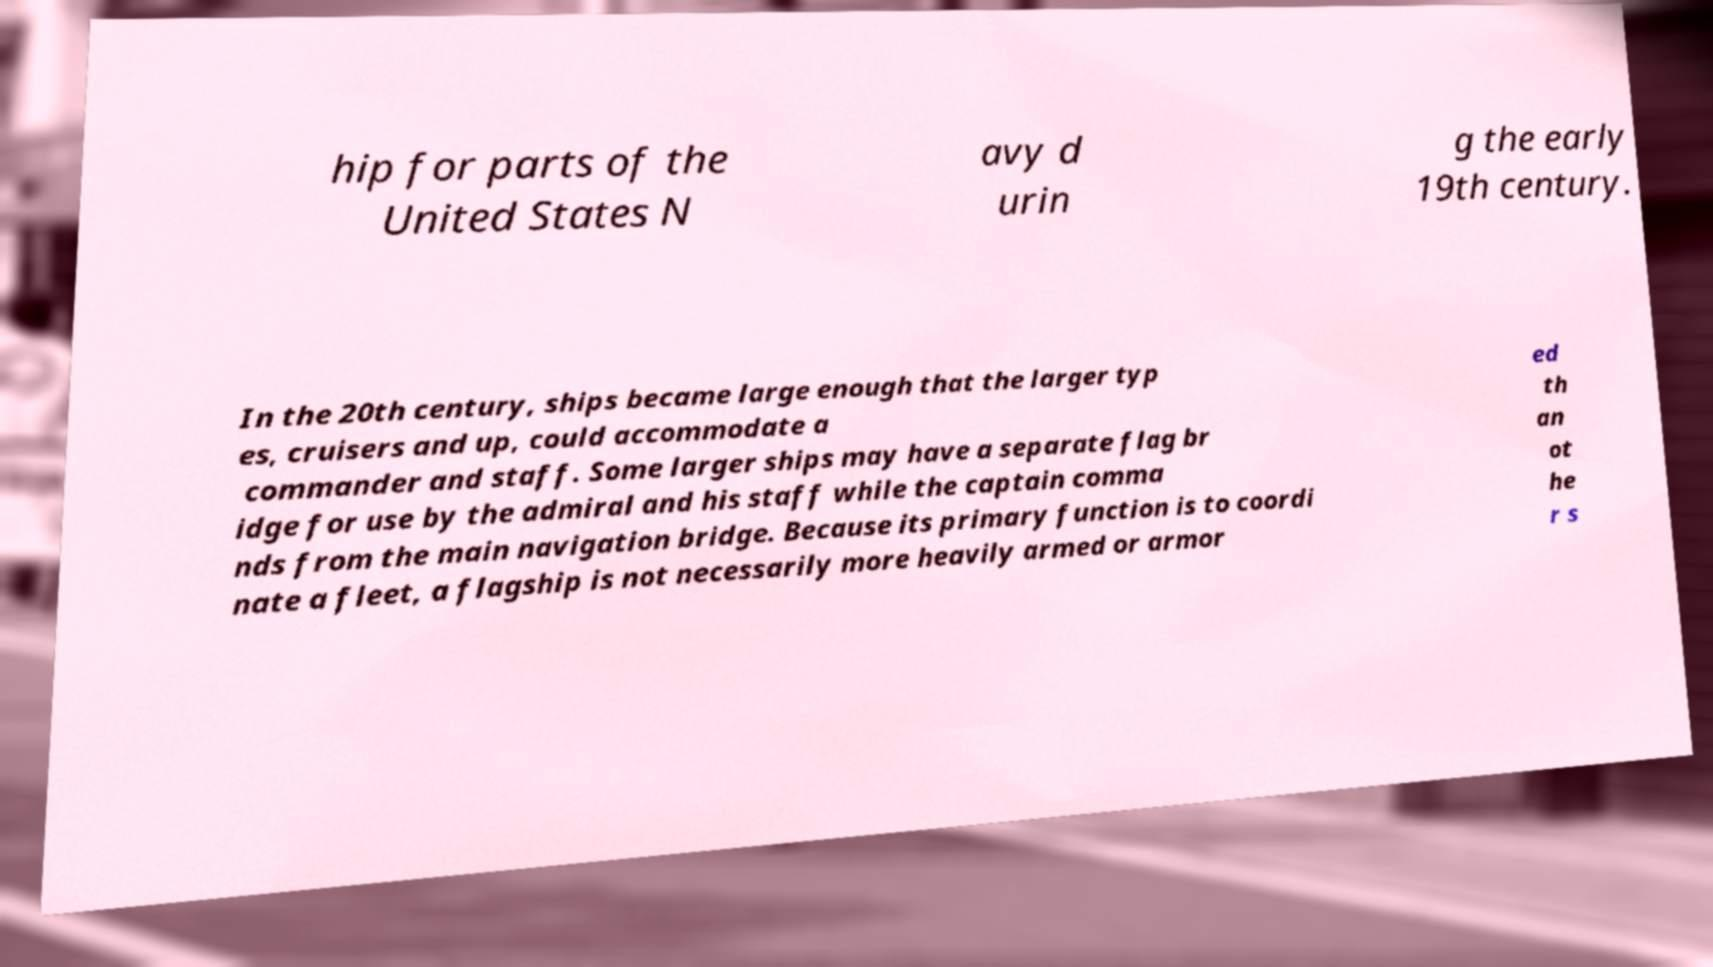Can you read and provide the text displayed in the image?This photo seems to have some interesting text. Can you extract and type it out for me? hip for parts of the United States N avy d urin g the early 19th century. In the 20th century, ships became large enough that the larger typ es, cruisers and up, could accommodate a commander and staff. Some larger ships may have a separate flag br idge for use by the admiral and his staff while the captain comma nds from the main navigation bridge. Because its primary function is to coordi nate a fleet, a flagship is not necessarily more heavily armed or armor ed th an ot he r s 